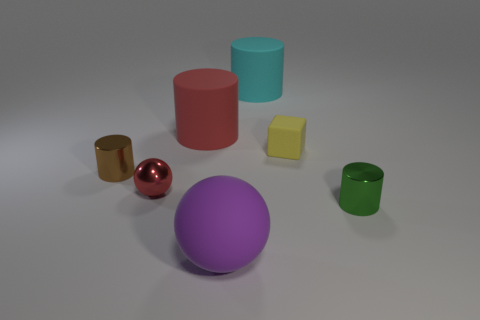Is the small yellow block made of the same material as the tiny brown cylinder?
Make the answer very short. No. Are there an equal number of cyan matte cylinders that are in front of the small brown metal object and large cylinders that are behind the large red rubber object?
Offer a terse response. No. What number of big matte balls are behind the green object?
Keep it short and to the point. 0. How many things are either large cylinders or small matte things?
Provide a succinct answer. 3. What number of brown cylinders are the same size as the purple sphere?
Your response must be concise. 0. What shape is the large thing left of the big rubber thing in front of the brown shiny thing?
Offer a very short reply. Cylinder. Is the number of big things less than the number of red spheres?
Keep it short and to the point. No. There is a small cylinder that is on the right side of the small yellow cube; what is its color?
Your answer should be very brief. Green. There is a cylinder that is on the right side of the red metallic object and on the left side of the large purple sphere; what material is it?
Your response must be concise. Rubber. What is the shape of the tiny yellow thing that is made of the same material as the large purple ball?
Your answer should be very brief. Cube. 